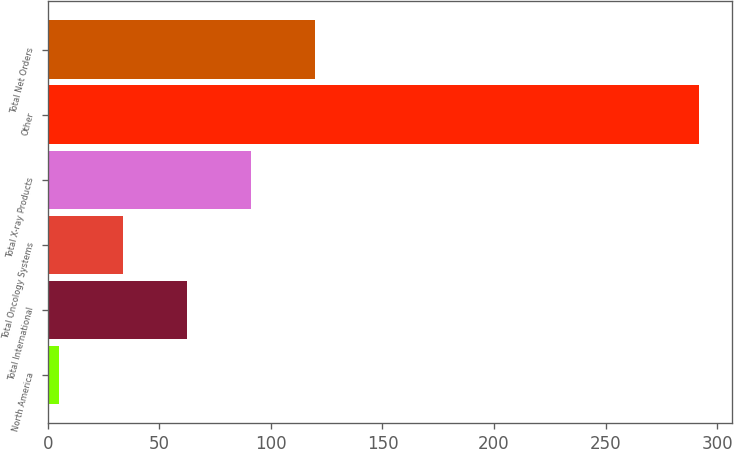Convert chart to OTSL. <chart><loc_0><loc_0><loc_500><loc_500><bar_chart><fcel>North America<fcel>Total International<fcel>Total Oncology Systems<fcel>Total X-ray Products<fcel>Other<fcel>Total Net Orders<nl><fcel>5<fcel>62.4<fcel>33.7<fcel>91.1<fcel>292<fcel>119.8<nl></chart> 